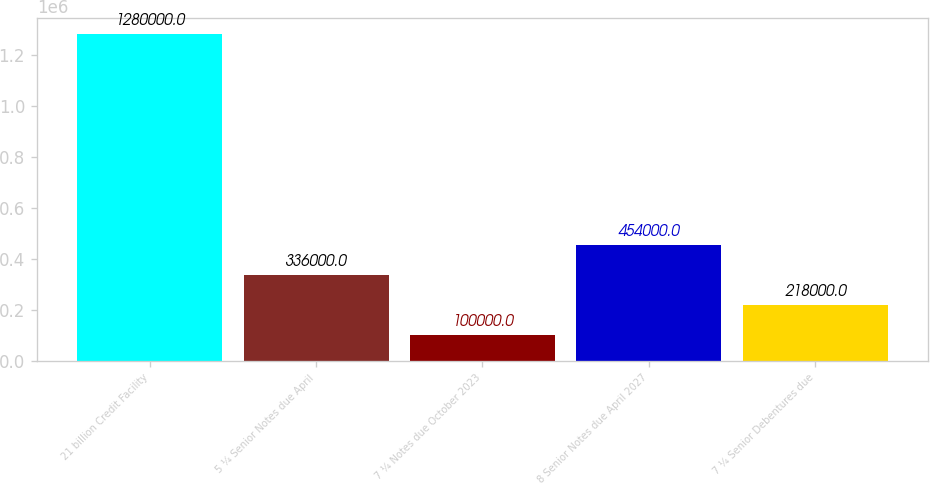Convert chart to OTSL. <chart><loc_0><loc_0><loc_500><loc_500><bar_chart><fcel>21 billion Credit Facility<fcel>5 ¼ Senior Notes due April<fcel>7 ¼ Notes due October 2023<fcel>8 Senior Notes due April 2027<fcel>7 ¼ Senior Debentures due<nl><fcel>1.28e+06<fcel>336000<fcel>100000<fcel>454000<fcel>218000<nl></chart> 